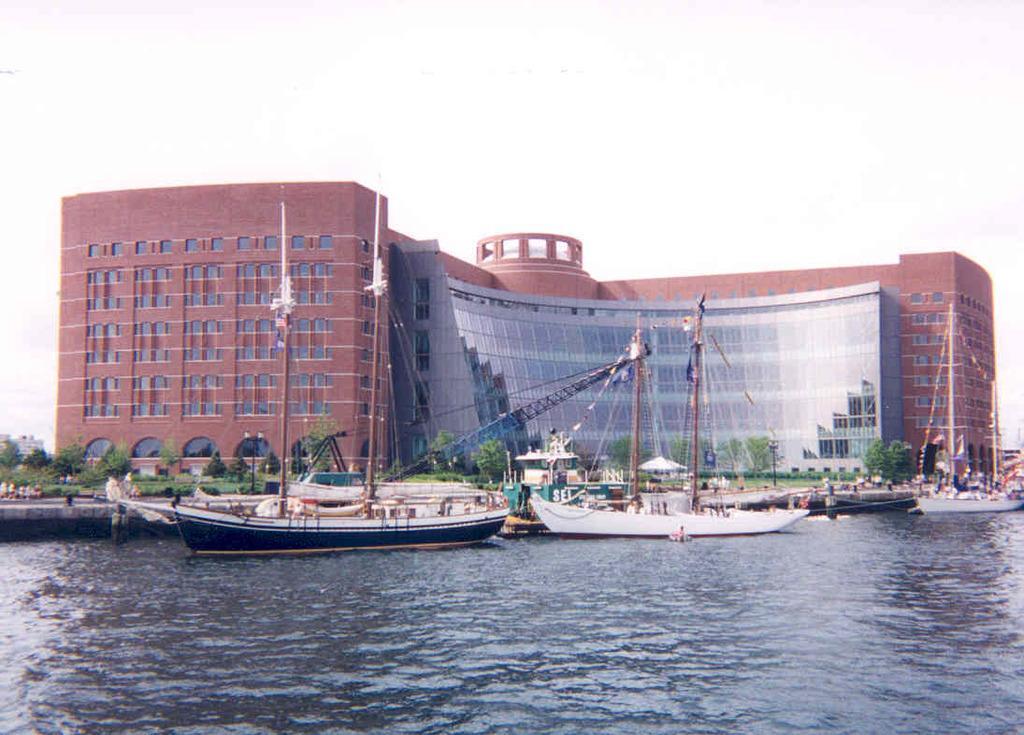Could you give a brief overview of what you see in this image? In the background we can see the sky and a wide building. In this picture we can see the trees, people. On the left side of the picture we can see the buildings. We can see the boats, poles, flags and the water. 